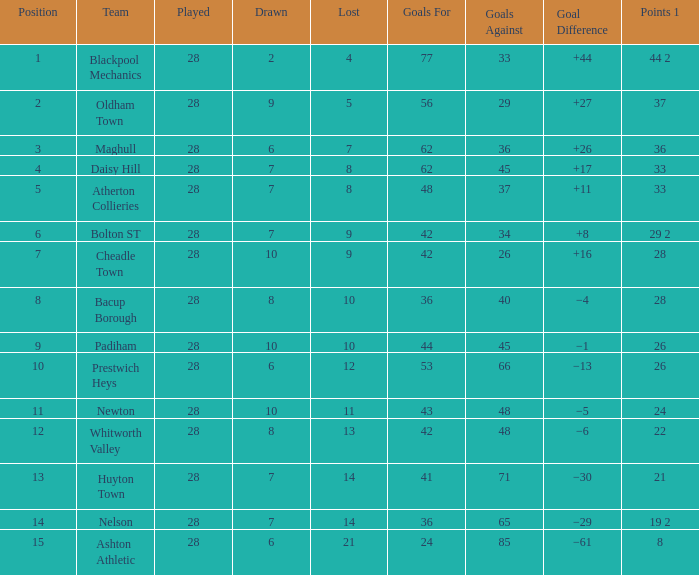What is the highest goals entry with drawn larger than 6 and goals against 85? None. 